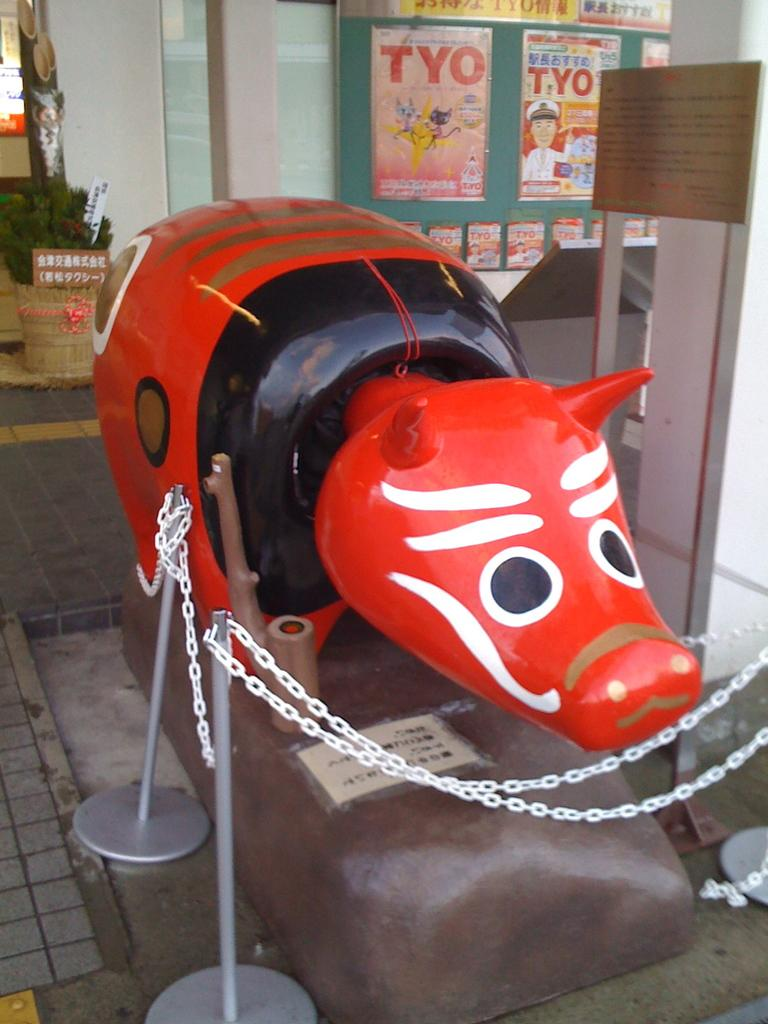What is the main subject in the center of the image? There is a toy in the center of the image. Can you describe the surroundings of the toy? There is a boundary around the toy. How does the toy contribute to the digestion process in the image? The toy does not contribute to the digestion process in the image, as it is not related to digestion. 